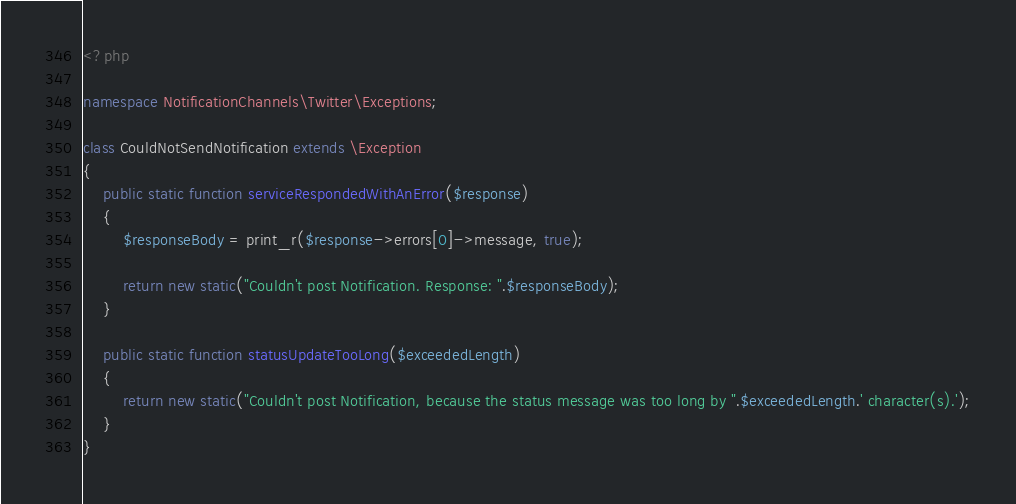Convert code to text. <code><loc_0><loc_0><loc_500><loc_500><_PHP_><?php

namespace NotificationChannels\Twitter\Exceptions;

class CouldNotSendNotification extends \Exception
{
    public static function serviceRespondedWithAnError($response)
    {
        $responseBody = print_r($response->errors[0]->message, true);

        return new static("Couldn't post Notification. Response: ".$responseBody);
    }

    public static function statusUpdateTooLong($exceededLength)
    {
        return new static("Couldn't post Notification, because the status message was too long by ".$exceededLength.' character(s).');
    }
}
</code> 